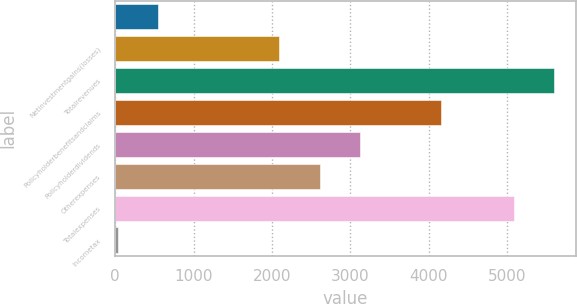<chart> <loc_0><loc_0><loc_500><loc_500><bar_chart><ecel><fcel>Netinvestmentgains(losses)<fcel>Totalrevenues<fcel>Policyholderbenefitsandclaims<fcel>Policyholderdividends<fcel>Otherexpenses<fcel>Totalexpenses<fcel>Incometax<nl><fcel>549<fcel>2094<fcel>5601<fcel>4154<fcel>3124<fcel>2609<fcel>5086<fcel>34<nl></chart> 